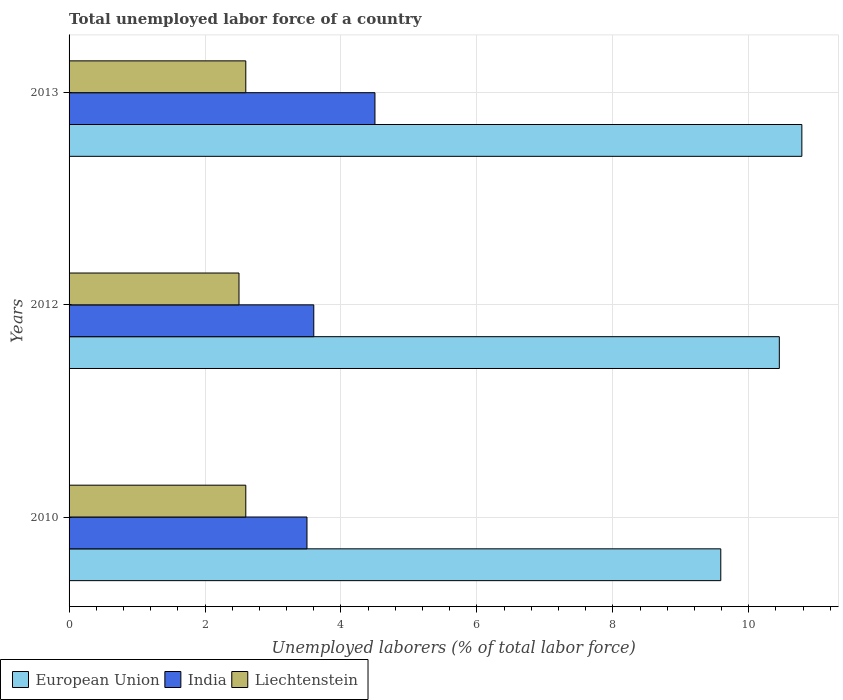How many different coloured bars are there?
Make the answer very short. 3. How many groups of bars are there?
Your response must be concise. 3. How many bars are there on the 1st tick from the bottom?
Offer a terse response. 3. What is the label of the 1st group of bars from the top?
Your response must be concise. 2013. In how many cases, is the number of bars for a given year not equal to the number of legend labels?
Keep it short and to the point. 0. What is the total unemployed labor force in European Union in 2012?
Give a very brief answer. 10.45. What is the total total unemployed labor force in India in the graph?
Provide a succinct answer. 11.6. What is the difference between the total unemployed labor force in India in 2012 and that in 2013?
Give a very brief answer. -0.9. What is the difference between the total unemployed labor force in Liechtenstein in 2010 and the total unemployed labor force in European Union in 2013?
Provide a short and direct response. -8.18. What is the average total unemployed labor force in Liechtenstein per year?
Give a very brief answer. 2.57. In the year 2013, what is the difference between the total unemployed labor force in India and total unemployed labor force in Liechtenstein?
Your response must be concise. 1.9. In how many years, is the total unemployed labor force in India greater than 4.4 %?
Ensure brevity in your answer.  1. What is the ratio of the total unemployed labor force in Liechtenstein in 2010 to that in 2013?
Your answer should be compact. 1. Is the total unemployed labor force in Liechtenstein in 2010 less than that in 2012?
Offer a terse response. No. Is the difference between the total unemployed labor force in India in 2010 and 2013 greater than the difference between the total unemployed labor force in Liechtenstein in 2010 and 2013?
Provide a succinct answer. No. What is the difference between the highest and the second highest total unemployed labor force in European Union?
Offer a very short reply. 0.33. What is the difference between the highest and the lowest total unemployed labor force in European Union?
Ensure brevity in your answer.  1.19. Is the sum of the total unemployed labor force in India in 2010 and 2013 greater than the maximum total unemployed labor force in European Union across all years?
Your answer should be very brief. No. What does the 3rd bar from the top in 2012 represents?
Ensure brevity in your answer.  European Union. What does the 3rd bar from the bottom in 2010 represents?
Offer a terse response. Liechtenstein. Is it the case that in every year, the sum of the total unemployed labor force in India and total unemployed labor force in Liechtenstein is greater than the total unemployed labor force in European Union?
Your response must be concise. No. How many bars are there?
Keep it short and to the point. 9. Are all the bars in the graph horizontal?
Your answer should be compact. Yes. What is the difference between two consecutive major ticks on the X-axis?
Keep it short and to the point. 2. Are the values on the major ticks of X-axis written in scientific E-notation?
Ensure brevity in your answer.  No. Does the graph contain any zero values?
Provide a succinct answer. No. Does the graph contain grids?
Give a very brief answer. Yes. Where does the legend appear in the graph?
Offer a terse response. Bottom left. How many legend labels are there?
Your answer should be compact. 3. What is the title of the graph?
Give a very brief answer. Total unemployed labor force of a country. Does "Mongolia" appear as one of the legend labels in the graph?
Keep it short and to the point. No. What is the label or title of the X-axis?
Offer a very short reply. Unemployed laborers (% of total labor force). What is the label or title of the Y-axis?
Ensure brevity in your answer.  Years. What is the Unemployed laborers (% of total labor force) of European Union in 2010?
Your answer should be compact. 9.59. What is the Unemployed laborers (% of total labor force) of Liechtenstein in 2010?
Your response must be concise. 2.6. What is the Unemployed laborers (% of total labor force) of European Union in 2012?
Ensure brevity in your answer.  10.45. What is the Unemployed laborers (% of total labor force) in India in 2012?
Provide a succinct answer. 3.6. What is the Unemployed laborers (% of total labor force) in Liechtenstein in 2012?
Keep it short and to the point. 2.5. What is the Unemployed laborers (% of total labor force) in European Union in 2013?
Make the answer very short. 10.78. What is the Unemployed laborers (% of total labor force) in Liechtenstein in 2013?
Your answer should be compact. 2.6. Across all years, what is the maximum Unemployed laborers (% of total labor force) of European Union?
Give a very brief answer. 10.78. Across all years, what is the maximum Unemployed laborers (% of total labor force) in India?
Provide a succinct answer. 4.5. Across all years, what is the maximum Unemployed laborers (% of total labor force) of Liechtenstein?
Your response must be concise. 2.6. Across all years, what is the minimum Unemployed laborers (% of total labor force) in European Union?
Provide a short and direct response. 9.59. Across all years, what is the minimum Unemployed laborers (% of total labor force) in Liechtenstein?
Provide a succinct answer. 2.5. What is the total Unemployed laborers (% of total labor force) of European Union in the graph?
Provide a short and direct response. 30.82. What is the total Unemployed laborers (% of total labor force) of India in the graph?
Offer a terse response. 11.6. What is the difference between the Unemployed laborers (% of total labor force) of European Union in 2010 and that in 2012?
Ensure brevity in your answer.  -0.86. What is the difference between the Unemployed laborers (% of total labor force) in European Union in 2010 and that in 2013?
Keep it short and to the point. -1.19. What is the difference between the Unemployed laborers (% of total labor force) in India in 2010 and that in 2013?
Give a very brief answer. -1. What is the difference between the Unemployed laborers (% of total labor force) of Liechtenstein in 2010 and that in 2013?
Your response must be concise. 0. What is the difference between the Unemployed laborers (% of total labor force) in European Union in 2012 and that in 2013?
Your response must be concise. -0.33. What is the difference between the Unemployed laborers (% of total labor force) in European Union in 2010 and the Unemployed laborers (% of total labor force) in India in 2012?
Your response must be concise. 5.99. What is the difference between the Unemployed laborers (% of total labor force) of European Union in 2010 and the Unemployed laborers (% of total labor force) of Liechtenstein in 2012?
Give a very brief answer. 7.09. What is the difference between the Unemployed laborers (% of total labor force) in India in 2010 and the Unemployed laborers (% of total labor force) in Liechtenstein in 2012?
Ensure brevity in your answer.  1. What is the difference between the Unemployed laborers (% of total labor force) of European Union in 2010 and the Unemployed laborers (% of total labor force) of India in 2013?
Provide a short and direct response. 5.09. What is the difference between the Unemployed laborers (% of total labor force) of European Union in 2010 and the Unemployed laborers (% of total labor force) of Liechtenstein in 2013?
Give a very brief answer. 6.99. What is the difference between the Unemployed laborers (% of total labor force) of European Union in 2012 and the Unemployed laborers (% of total labor force) of India in 2013?
Give a very brief answer. 5.95. What is the difference between the Unemployed laborers (% of total labor force) of European Union in 2012 and the Unemployed laborers (% of total labor force) of Liechtenstein in 2013?
Ensure brevity in your answer.  7.85. What is the average Unemployed laborers (% of total labor force) in European Union per year?
Give a very brief answer. 10.27. What is the average Unemployed laborers (% of total labor force) of India per year?
Offer a terse response. 3.87. What is the average Unemployed laborers (% of total labor force) of Liechtenstein per year?
Keep it short and to the point. 2.57. In the year 2010, what is the difference between the Unemployed laborers (% of total labor force) in European Union and Unemployed laborers (% of total labor force) in India?
Your answer should be compact. 6.09. In the year 2010, what is the difference between the Unemployed laborers (% of total labor force) of European Union and Unemployed laborers (% of total labor force) of Liechtenstein?
Provide a short and direct response. 6.99. In the year 2010, what is the difference between the Unemployed laborers (% of total labor force) of India and Unemployed laborers (% of total labor force) of Liechtenstein?
Provide a succinct answer. 0.9. In the year 2012, what is the difference between the Unemployed laborers (% of total labor force) in European Union and Unemployed laborers (% of total labor force) in India?
Make the answer very short. 6.85. In the year 2012, what is the difference between the Unemployed laborers (% of total labor force) of European Union and Unemployed laborers (% of total labor force) of Liechtenstein?
Provide a short and direct response. 7.95. In the year 2013, what is the difference between the Unemployed laborers (% of total labor force) in European Union and Unemployed laborers (% of total labor force) in India?
Your response must be concise. 6.28. In the year 2013, what is the difference between the Unemployed laborers (% of total labor force) in European Union and Unemployed laborers (% of total labor force) in Liechtenstein?
Ensure brevity in your answer.  8.18. What is the ratio of the Unemployed laborers (% of total labor force) of European Union in 2010 to that in 2012?
Keep it short and to the point. 0.92. What is the ratio of the Unemployed laborers (% of total labor force) of India in 2010 to that in 2012?
Make the answer very short. 0.97. What is the ratio of the Unemployed laborers (% of total labor force) of Liechtenstein in 2010 to that in 2012?
Your answer should be very brief. 1.04. What is the ratio of the Unemployed laborers (% of total labor force) in European Union in 2010 to that in 2013?
Your answer should be compact. 0.89. What is the ratio of the Unemployed laborers (% of total labor force) of India in 2010 to that in 2013?
Make the answer very short. 0.78. What is the ratio of the Unemployed laborers (% of total labor force) in Liechtenstein in 2010 to that in 2013?
Offer a terse response. 1. What is the ratio of the Unemployed laborers (% of total labor force) in European Union in 2012 to that in 2013?
Make the answer very short. 0.97. What is the ratio of the Unemployed laborers (% of total labor force) in Liechtenstein in 2012 to that in 2013?
Your answer should be compact. 0.96. What is the difference between the highest and the second highest Unemployed laborers (% of total labor force) of European Union?
Your answer should be compact. 0.33. What is the difference between the highest and the lowest Unemployed laborers (% of total labor force) in European Union?
Offer a very short reply. 1.19. 